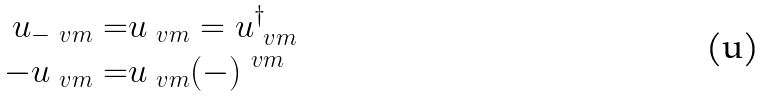<formula> <loc_0><loc_0><loc_500><loc_500>u _ { - \ v m } = & u _ { \ v m } = u _ { \ v m } ^ { \dag } \\ - u _ { \ v m } = & u _ { \ v m } ( - ) ^ { \ v m }</formula> 